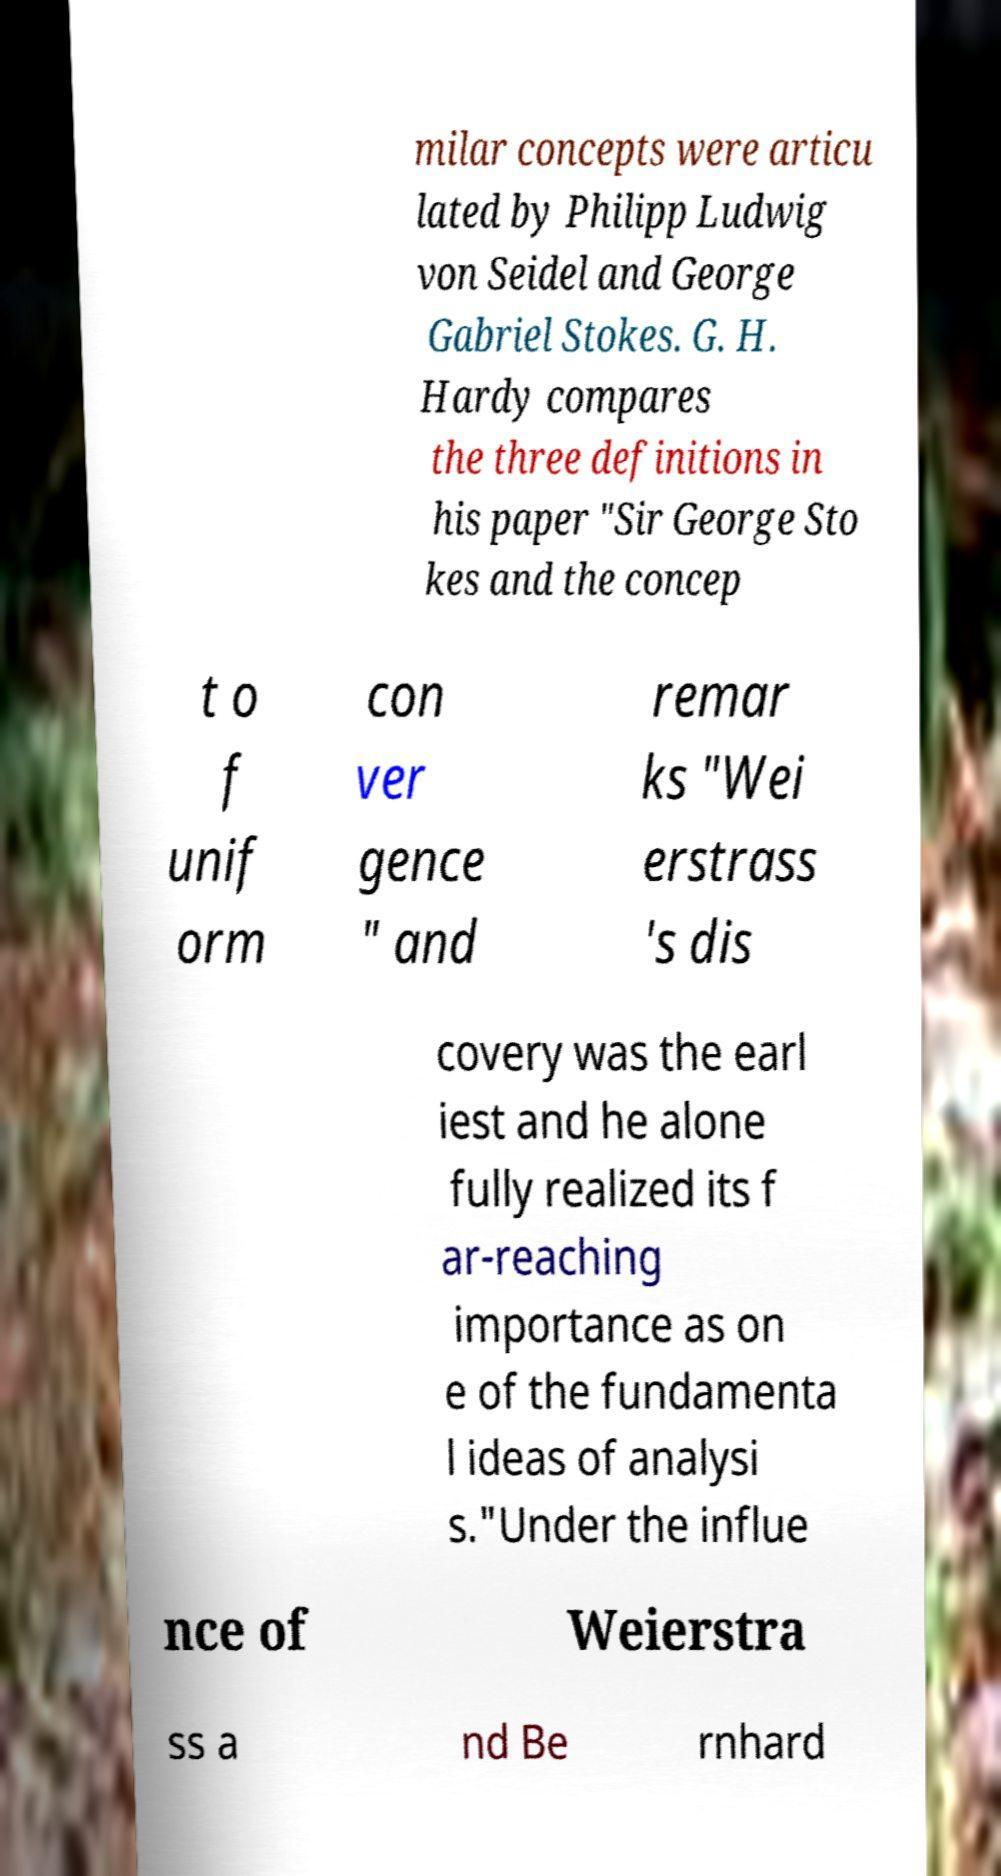Can you read and provide the text displayed in the image?This photo seems to have some interesting text. Can you extract and type it out for me? milar concepts were articu lated by Philipp Ludwig von Seidel and George Gabriel Stokes. G. H. Hardy compares the three definitions in his paper "Sir George Sto kes and the concep t o f unif orm con ver gence " and remar ks "Wei erstrass 's dis covery was the earl iest and he alone fully realized its f ar-reaching importance as on e of the fundamenta l ideas of analysi s."Under the influe nce of Weierstra ss a nd Be rnhard 